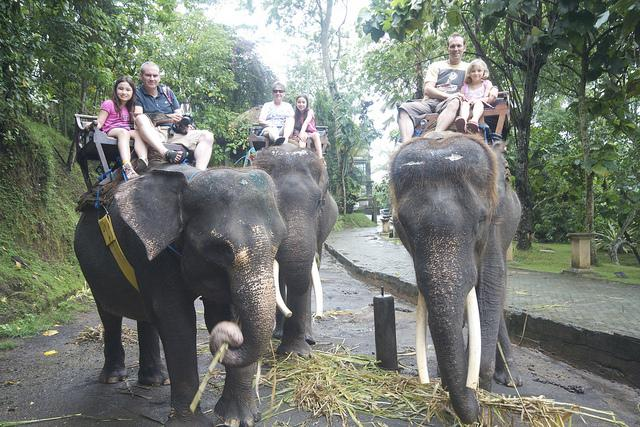How many elephants are standing in the road with people on their backs? three 